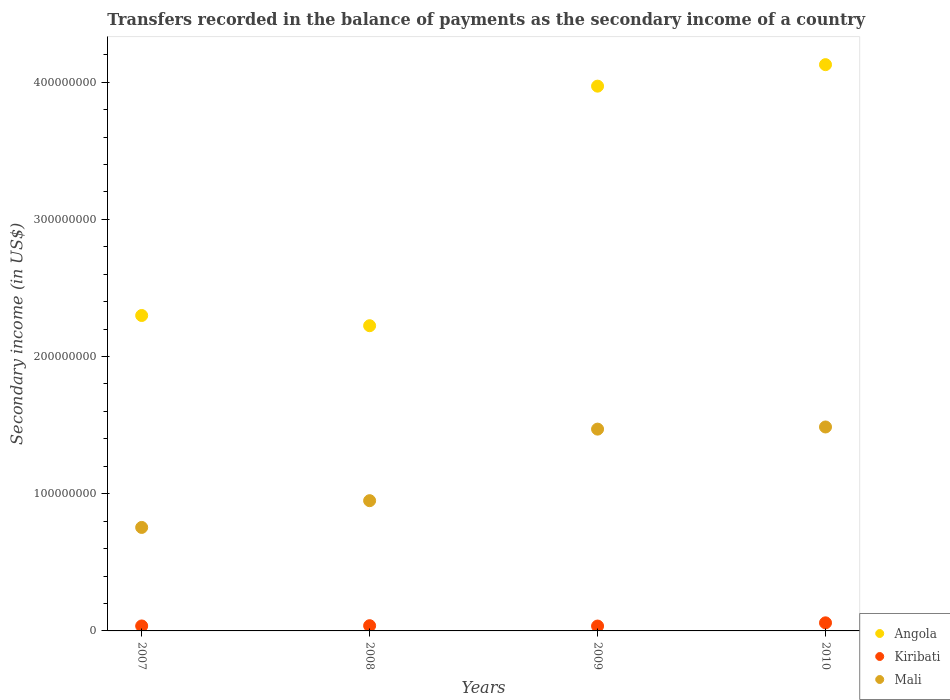Is the number of dotlines equal to the number of legend labels?
Give a very brief answer. Yes. What is the secondary income of in Angola in 2007?
Provide a succinct answer. 2.30e+08. Across all years, what is the maximum secondary income of in Mali?
Your answer should be very brief. 1.49e+08. Across all years, what is the minimum secondary income of in Angola?
Your answer should be very brief. 2.22e+08. In which year was the secondary income of in Kiribati maximum?
Your answer should be compact. 2010. What is the total secondary income of in Kiribati in the graph?
Make the answer very short. 1.69e+07. What is the difference between the secondary income of in Angola in 2007 and that in 2008?
Ensure brevity in your answer.  7.45e+06. What is the difference between the secondary income of in Mali in 2009 and the secondary income of in Kiribati in 2008?
Make the answer very short. 1.43e+08. What is the average secondary income of in Kiribati per year?
Give a very brief answer. 4.22e+06. In the year 2009, what is the difference between the secondary income of in Mali and secondary income of in Kiribati?
Give a very brief answer. 1.44e+08. In how many years, is the secondary income of in Mali greater than 360000000 US$?
Keep it short and to the point. 0. What is the ratio of the secondary income of in Kiribati in 2007 to that in 2010?
Offer a very short reply. 0.61. What is the difference between the highest and the second highest secondary income of in Mali?
Offer a terse response. 1.56e+06. What is the difference between the highest and the lowest secondary income of in Kiribati?
Provide a succinct answer. 2.35e+06. In how many years, is the secondary income of in Mali greater than the average secondary income of in Mali taken over all years?
Make the answer very short. 2. Is it the case that in every year, the sum of the secondary income of in Kiribati and secondary income of in Mali  is greater than the secondary income of in Angola?
Ensure brevity in your answer.  No. Is the secondary income of in Mali strictly greater than the secondary income of in Angola over the years?
Your answer should be very brief. No. Is the secondary income of in Mali strictly less than the secondary income of in Kiribati over the years?
Ensure brevity in your answer.  No. How many years are there in the graph?
Give a very brief answer. 4. What is the difference between two consecutive major ticks on the Y-axis?
Provide a short and direct response. 1.00e+08. Are the values on the major ticks of Y-axis written in scientific E-notation?
Give a very brief answer. No. Does the graph contain grids?
Keep it short and to the point. No. Where does the legend appear in the graph?
Make the answer very short. Bottom right. What is the title of the graph?
Give a very brief answer. Transfers recorded in the balance of payments as the secondary income of a country. Does "Upper middle income" appear as one of the legend labels in the graph?
Provide a succinct answer. No. What is the label or title of the X-axis?
Provide a succinct answer. Years. What is the label or title of the Y-axis?
Offer a very short reply. Secondary income (in US$). What is the Secondary income (in US$) in Angola in 2007?
Make the answer very short. 2.30e+08. What is the Secondary income (in US$) of Kiribati in 2007?
Your response must be concise. 3.62e+06. What is the Secondary income (in US$) of Mali in 2007?
Ensure brevity in your answer.  7.54e+07. What is the Secondary income (in US$) in Angola in 2008?
Your answer should be very brief. 2.22e+08. What is the Secondary income (in US$) of Kiribati in 2008?
Offer a terse response. 3.81e+06. What is the Secondary income (in US$) in Mali in 2008?
Ensure brevity in your answer.  9.49e+07. What is the Secondary income (in US$) in Angola in 2009?
Provide a succinct answer. 3.97e+08. What is the Secondary income (in US$) of Kiribati in 2009?
Offer a terse response. 3.55e+06. What is the Secondary income (in US$) in Mali in 2009?
Your answer should be very brief. 1.47e+08. What is the Secondary income (in US$) in Angola in 2010?
Provide a succinct answer. 4.13e+08. What is the Secondary income (in US$) of Kiribati in 2010?
Your answer should be very brief. 5.89e+06. What is the Secondary income (in US$) in Mali in 2010?
Offer a terse response. 1.49e+08. Across all years, what is the maximum Secondary income (in US$) in Angola?
Offer a terse response. 4.13e+08. Across all years, what is the maximum Secondary income (in US$) in Kiribati?
Your answer should be compact. 5.89e+06. Across all years, what is the maximum Secondary income (in US$) in Mali?
Make the answer very short. 1.49e+08. Across all years, what is the minimum Secondary income (in US$) in Angola?
Ensure brevity in your answer.  2.22e+08. Across all years, what is the minimum Secondary income (in US$) in Kiribati?
Ensure brevity in your answer.  3.55e+06. Across all years, what is the minimum Secondary income (in US$) in Mali?
Ensure brevity in your answer.  7.54e+07. What is the total Secondary income (in US$) in Angola in the graph?
Provide a succinct answer. 1.26e+09. What is the total Secondary income (in US$) of Kiribati in the graph?
Provide a succinct answer. 1.69e+07. What is the total Secondary income (in US$) of Mali in the graph?
Give a very brief answer. 4.66e+08. What is the difference between the Secondary income (in US$) of Angola in 2007 and that in 2008?
Provide a succinct answer. 7.45e+06. What is the difference between the Secondary income (in US$) in Kiribati in 2007 and that in 2008?
Make the answer very short. -1.90e+05. What is the difference between the Secondary income (in US$) in Mali in 2007 and that in 2008?
Keep it short and to the point. -1.95e+07. What is the difference between the Secondary income (in US$) in Angola in 2007 and that in 2009?
Your answer should be compact. -1.67e+08. What is the difference between the Secondary income (in US$) of Kiribati in 2007 and that in 2009?
Your answer should be very brief. 6.99e+04. What is the difference between the Secondary income (in US$) of Mali in 2007 and that in 2009?
Make the answer very short. -7.17e+07. What is the difference between the Secondary income (in US$) of Angola in 2007 and that in 2010?
Your answer should be compact. -1.83e+08. What is the difference between the Secondary income (in US$) of Kiribati in 2007 and that in 2010?
Provide a succinct answer. -2.28e+06. What is the difference between the Secondary income (in US$) in Mali in 2007 and that in 2010?
Your answer should be compact. -7.32e+07. What is the difference between the Secondary income (in US$) of Angola in 2008 and that in 2009?
Ensure brevity in your answer.  -1.75e+08. What is the difference between the Secondary income (in US$) of Kiribati in 2008 and that in 2009?
Keep it short and to the point. 2.60e+05. What is the difference between the Secondary income (in US$) of Mali in 2008 and that in 2009?
Offer a very short reply. -5.22e+07. What is the difference between the Secondary income (in US$) in Angola in 2008 and that in 2010?
Provide a short and direct response. -1.90e+08. What is the difference between the Secondary income (in US$) in Kiribati in 2008 and that in 2010?
Your response must be concise. -2.09e+06. What is the difference between the Secondary income (in US$) in Mali in 2008 and that in 2010?
Offer a very short reply. -5.37e+07. What is the difference between the Secondary income (in US$) in Angola in 2009 and that in 2010?
Your answer should be very brief. -1.57e+07. What is the difference between the Secondary income (in US$) in Kiribati in 2009 and that in 2010?
Offer a terse response. -2.35e+06. What is the difference between the Secondary income (in US$) in Mali in 2009 and that in 2010?
Offer a terse response. -1.56e+06. What is the difference between the Secondary income (in US$) of Angola in 2007 and the Secondary income (in US$) of Kiribati in 2008?
Ensure brevity in your answer.  2.26e+08. What is the difference between the Secondary income (in US$) in Angola in 2007 and the Secondary income (in US$) in Mali in 2008?
Your answer should be very brief. 1.35e+08. What is the difference between the Secondary income (in US$) in Kiribati in 2007 and the Secondary income (in US$) in Mali in 2008?
Give a very brief answer. -9.13e+07. What is the difference between the Secondary income (in US$) of Angola in 2007 and the Secondary income (in US$) of Kiribati in 2009?
Provide a succinct answer. 2.26e+08. What is the difference between the Secondary income (in US$) of Angola in 2007 and the Secondary income (in US$) of Mali in 2009?
Provide a short and direct response. 8.28e+07. What is the difference between the Secondary income (in US$) in Kiribati in 2007 and the Secondary income (in US$) in Mali in 2009?
Your answer should be very brief. -1.43e+08. What is the difference between the Secondary income (in US$) in Angola in 2007 and the Secondary income (in US$) in Kiribati in 2010?
Keep it short and to the point. 2.24e+08. What is the difference between the Secondary income (in US$) in Angola in 2007 and the Secondary income (in US$) in Mali in 2010?
Provide a succinct answer. 8.13e+07. What is the difference between the Secondary income (in US$) in Kiribati in 2007 and the Secondary income (in US$) in Mali in 2010?
Keep it short and to the point. -1.45e+08. What is the difference between the Secondary income (in US$) in Angola in 2008 and the Secondary income (in US$) in Kiribati in 2009?
Ensure brevity in your answer.  2.19e+08. What is the difference between the Secondary income (in US$) of Angola in 2008 and the Secondary income (in US$) of Mali in 2009?
Keep it short and to the point. 7.54e+07. What is the difference between the Secondary income (in US$) in Kiribati in 2008 and the Secondary income (in US$) in Mali in 2009?
Give a very brief answer. -1.43e+08. What is the difference between the Secondary income (in US$) in Angola in 2008 and the Secondary income (in US$) in Kiribati in 2010?
Your answer should be very brief. 2.17e+08. What is the difference between the Secondary income (in US$) of Angola in 2008 and the Secondary income (in US$) of Mali in 2010?
Keep it short and to the point. 7.38e+07. What is the difference between the Secondary income (in US$) of Kiribati in 2008 and the Secondary income (in US$) of Mali in 2010?
Keep it short and to the point. -1.45e+08. What is the difference between the Secondary income (in US$) in Angola in 2009 and the Secondary income (in US$) in Kiribati in 2010?
Your answer should be compact. 3.91e+08. What is the difference between the Secondary income (in US$) in Angola in 2009 and the Secondary income (in US$) in Mali in 2010?
Keep it short and to the point. 2.48e+08. What is the difference between the Secondary income (in US$) of Kiribati in 2009 and the Secondary income (in US$) of Mali in 2010?
Keep it short and to the point. -1.45e+08. What is the average Secondary income (in US$) of Angola per year?
Offer a terse response. 3.16e+08. What is the average Secondary income (in US$) of Kiribati per year?
Your answer should be compact. 4.22e+06. What is the average Secondary income (in US$) of Mali per year?
Your response must be concise. 1.17e+08. In the year 2007, what is the difference between the Secondary income (in US$) in Angola and Secondary income (in US$) in Kiribati?
Keep it short and to the point. 2.26e+08. In the year 2007, what is the difference between the Secondary income (in US$) in Angola and Secondary income (in US$) in Mali?
Provide a succinct answer. 1.54e+08. In the year 2007, what is the difference between the Secondary income (in US$) in Kiribati and Secondary income (in US$) in Mali?
Offer a very short reply. -7.18e+07. In the year 2008, what is the difference between the Secondary income (in US$) of Angola and Secondary income (in US$) of Kiribati?
Keep it short and to the point. 2.19e+08. In the year 2008, what is the difference between the Secondary income (in US$) in Angola and Secondary income (in US$) in Mali?
Make the answer very short. 1.28e+08. In the year 2008, what is the difference between the Secondary income (in US$) in Kiribati and Secondary income (in US$) in Mali?
Make the answer very short. -9.11e+07. In the year 2009, what is the difference between the Secondary income (in US$) in Angola and Secondary income (in US$) in Kiribati?
Your answer should be compact. 3.94e+08. In the year 2009, what is the difference between the Secondary income (in US$) in Angola and Secondary income (in US$) in Mali?
Make the answer very short. 2.50e+08. In the year 2009, what is the difference between the Secondary income (in US$) in Kiribati and Secondary income (in US$) in Mali?
Your answer should be very brief. -1.44e+08. In the year 2010, what is the difference between the Secondary income (in US$) in Angola and Secondary income (in US$) in Kiribati?
Keep it short and to the point. 4.07e+08. In the year 2010, what is the difference between the Secondary income (in US$) in Angola and Secondary income (in US$) in Mali?
Provide a succinct answer. 2.64e+08. In the year 2010, what is the difference between the Secondary income (in US$) of Kiribati and Secondary income (in US$) of Mali?
Offer a very short reply. -1.43e+08. What is the ratio of the Secondary income (in US$) of Angola in 2007 to that in 2008?
Your answer should be compact. 1.03. What is the ratio of the Secondary income (in US$) of Mali in 2007 to that in 2008?
Offer a very short reply. 0.79. What is the ratio of the Secondary income (in US$) in Angola in 2007 to that in 2009?
Provide a short and direct response. 0.58. What is the ratio of the Secondary income (in US$) of Kiribati in 2007 to that in 2009?
Provide a short and direct response. 1.02. What is the ratio of the Secondary income (in US$) in Mali in 2007 to that in 2009?
Make the answer very short. 0.51. What is the ratio of the Secondary income (in US$) of Angola in 2007 to that in 2010?
Your answer should be very brief. 0.56. What is the ratio of the Secondary income (in US$) in Kiribati in 2007 to that in 2010?
Give a very brief answer. 0.61. What is the ratio of the Secondary income (in US$) in Mali in 2007 to that in 2010?
Your answer should be compact. 0.51. What is the ratio of the Secondary income (in US$) of Angola in 2008 to that in 2009?
Give a very brief answer. 0.56. What is the ratio of the Secondary income (in US$) in Kiribati in 2008 to that in 2009?
Give a very brief answer. 1.07. What is the ratio of the Secondary income (in US$) in Mali in 2008 to that in 2009?
Ensure brevity in your answer.  0.65. What is the ratio of the Secondary income (in US$) in Angola in 2008 to that in 2010?
Provide a short and direct response. 0.54. What is the ratio of the Secondary income (in US$) in Kiribati in 2008 to that in 2010?
Ensure brevity in your answer.  0.65. What is the ratio of the Secondary income (in US$) of Mali in 2008 to that in 2010?
Offer a very short reply. 0.64. What is the ratio of the Secondary income (in US$) in Kiribati in 2009 to that in 2010?
Provide a succinct answer. 0.6. What is the difference between the highest and the second highest Secondary income (in US$) in Angola?
Make the answer very short. 1.57e+07. What is the difference between the highest and the second highest Secondary income (in US$) of Kiribati?
Your answer should be very brief. 2.09e+06. What is the difference between the highest and the second highest Secondary income (in US$) of Mali?
Provide a succinct answer. 1.56e+06. What is the difference between the highest and the lowest Secondary income (in US$) in Angola?
Offer a terse response. 1.90e+08. What is the difference between the highest and the lowest Secondary income (in US$) of Kiribati?
Ensure brevity in your answer.  2.35e+06. What is the difference between the highest and the lowest Secondary income (in US$) in Mali?
Your answer should be compact. 7.32e+07. 